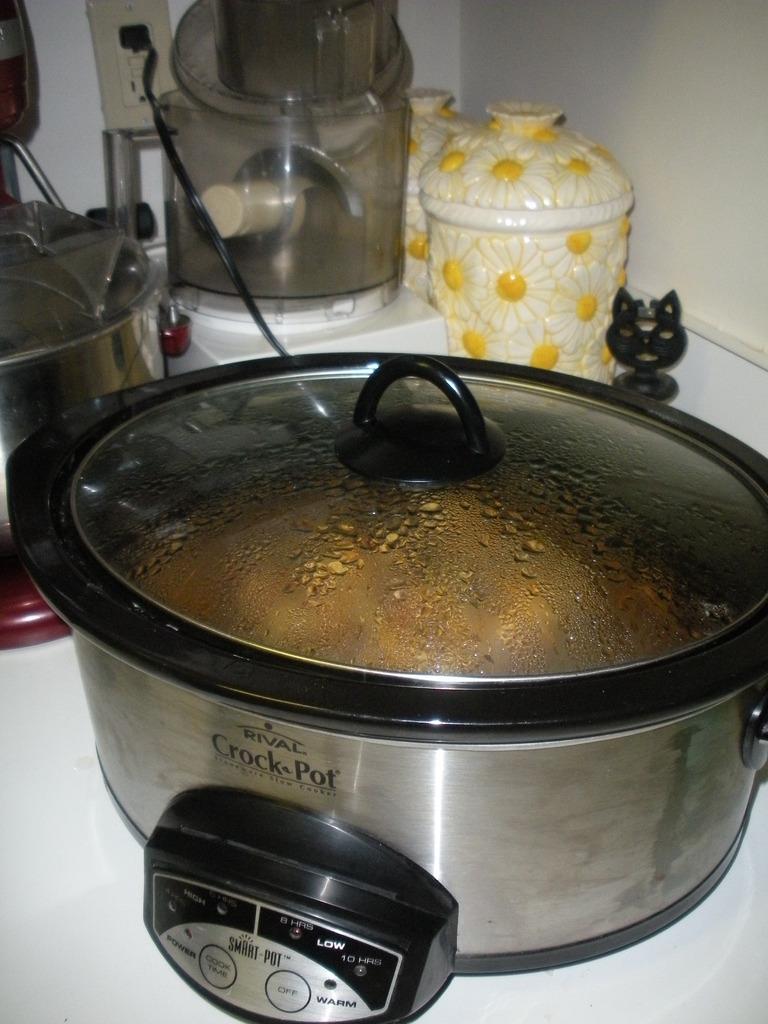What type of cookware is this?
Make the answer very short. Crock pot. 